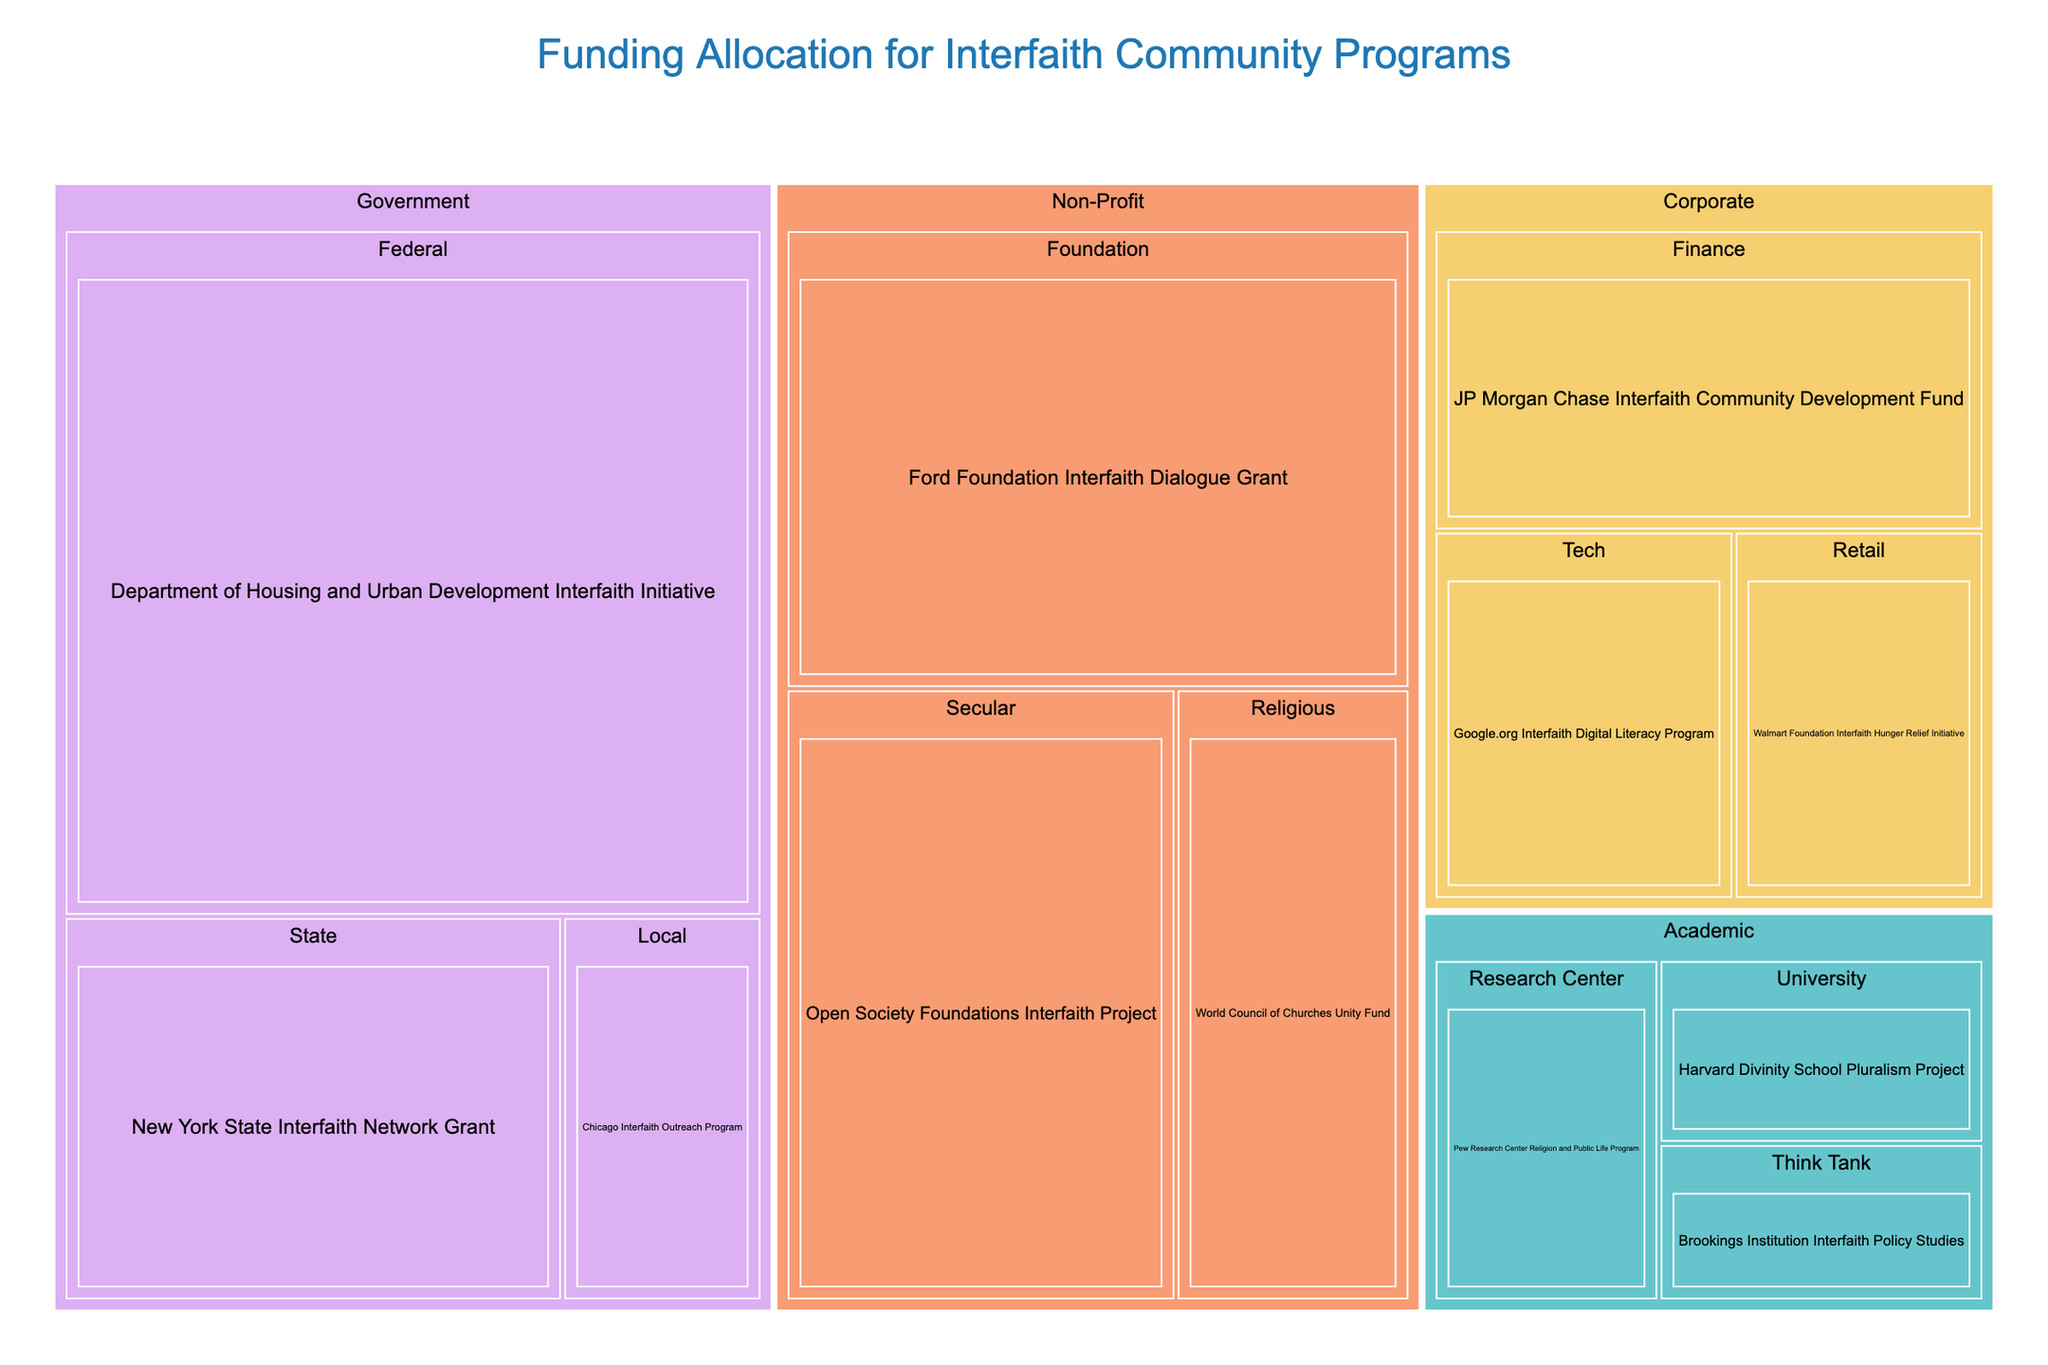What's the total funding allocated to Government sector programs? The Government sector includes three programs with funding amounts of $5,000,000, $2,000,000, and $800,000. Summing these values gives the total funding: $5,000,000 + $2,000,000 + $800,000 = $7,800,000
Answer: $7,800,000 How much more funding does the Federal category receive compared to the State category within the Government sector? The Federal category receives $5,000,000 and the State category receives $2,000,000. The difference is $5,000,000 - $2,000,000 = $3,000,000
Answer: $3,000,000 Which sector receives the highest amount of funding? By comparing the total funding of each sector: Government, Non-Profit, Corporate, and Academic, the Government sector has the highest amount with $7,800,000
Answer: Government What is the smallest amount of funding allocated to a program within the Academic sector? The three programs in the Academic sector are funded with $700,000, $900,000, and $600,000. The smallest amount is $600,000
Answer: $600,000 Compare the total funding between Non-Profit and Corporate sectors. Which one has more funding and by how much? Total funding for the Non-Profit sector is $3,000,000 + $1,500,000 + $2,500,000 = $7,000,000 and for the Corporate sector is $1,200,000 + $1,800,000 + $1,000,000 = $4,000,000. Non-Profit has more funding by $7,000,000 - $4,000,000 = $3,000,000
Answer: Non-Profit, $3,000,000 In the Corporate sector, which category has the highest funding? The three categories within Corporate (Tech, Finance, and Retail) have funding amounts of $1,200,000, $1,800,000, and $1,000,000 respectively. The highest funded category is Finance
Answer: Finance What is the combined funding for Tech and Retail categories in the Corporate sector? The Tech category receives $1,200,000 and the Retail category receives $1,000,000. Combined funding is $1,200,000 + $1,000,000 = $2,200,000
Answer: $2,200,000 How does funding in the Harvard Divinity School Pluralism Project compare to the Pew Research Center Religion and Public Life Program? Harvard Divinity School Pluralism Project receives $700,000 and Pew Research Center Religion and Public Life Program receives $900,000. The difference is $900,000 - $700,000 = $200,000
Answer: Pew Research Center receives $200,000 more Which specific program receives the highest funding in the figure overall? Out of all the programs listed, the Department of Housing and Urban Development Interfaith Initiative in the Federal category receives the highest funding of $5,000,000
Answer: Department of Housing and Urban Development Interfaith Initiative What is the average funding per program in the Non-Profit sector? There are 3 programs in the Non-Profit sector with total funding of $3,000,000 + $1,500,000 + $2,500,000 = $7,000,000. The average funding per program is $7,000,000 / 3 = $2,333,333.33
Answer: $2,333,333.33 